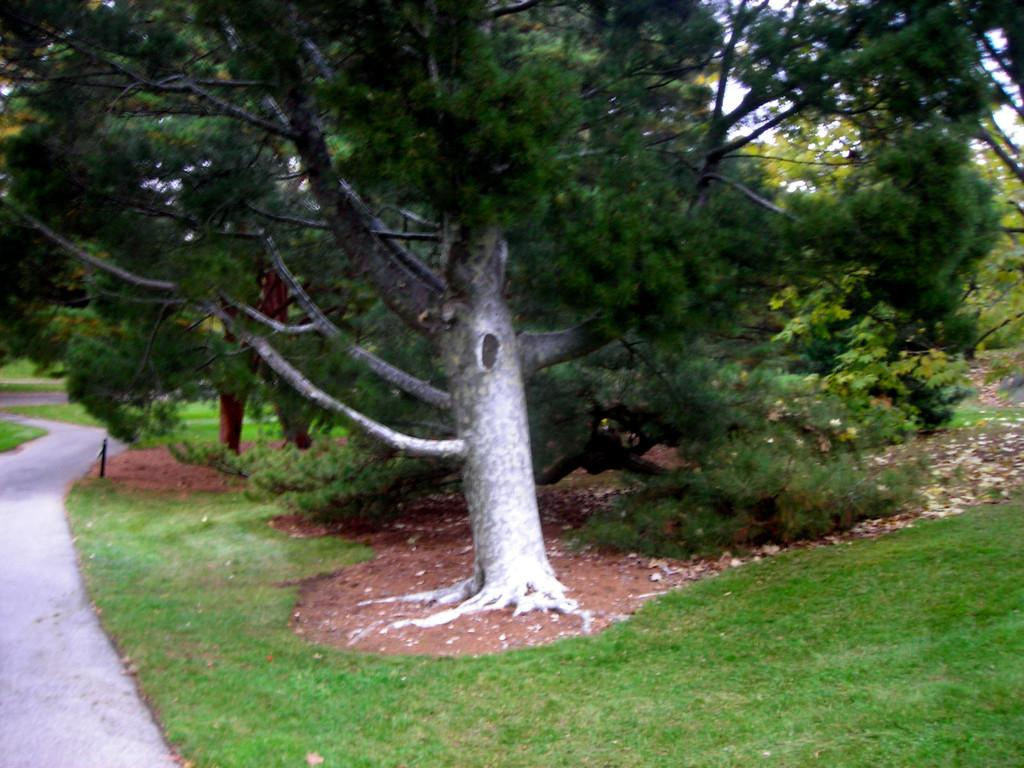What can be seen in the foreground of the picture? There is a path and grass in the foreground of the picture. What elements are present in the center of the picture? There are dry leaves, soil, grass, and trees in the center of the picture. What is visible in the background of the picture? There are trees and grass in the background of the picture. How many arms are visible in the picture? There are no arms visible in the picture; it features a natural landscape with paths, grass, and trees. What type of wood can be seen in the picture? There is no wood present in the picture; it features a natural landscape with paths, grass, and trees. 